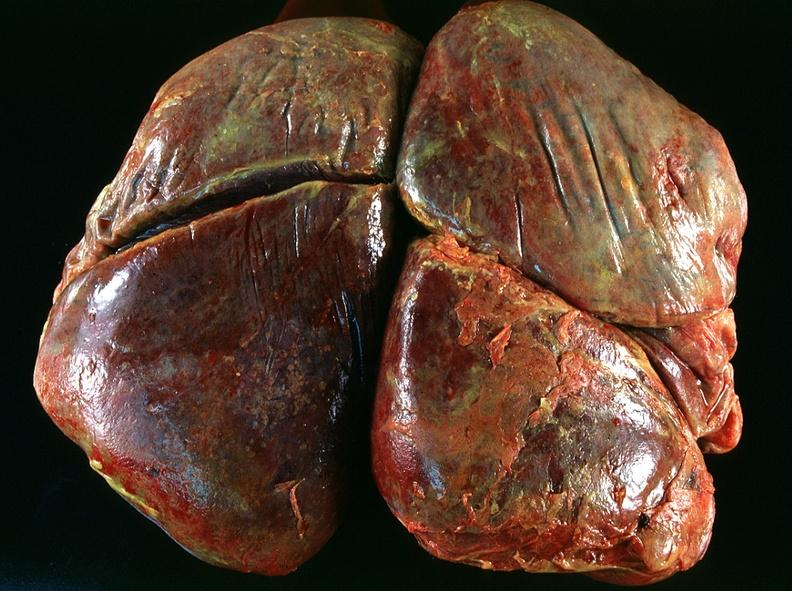s hemorrhagic corpus luteum present?
Answer the question using a single word or phrase. No 